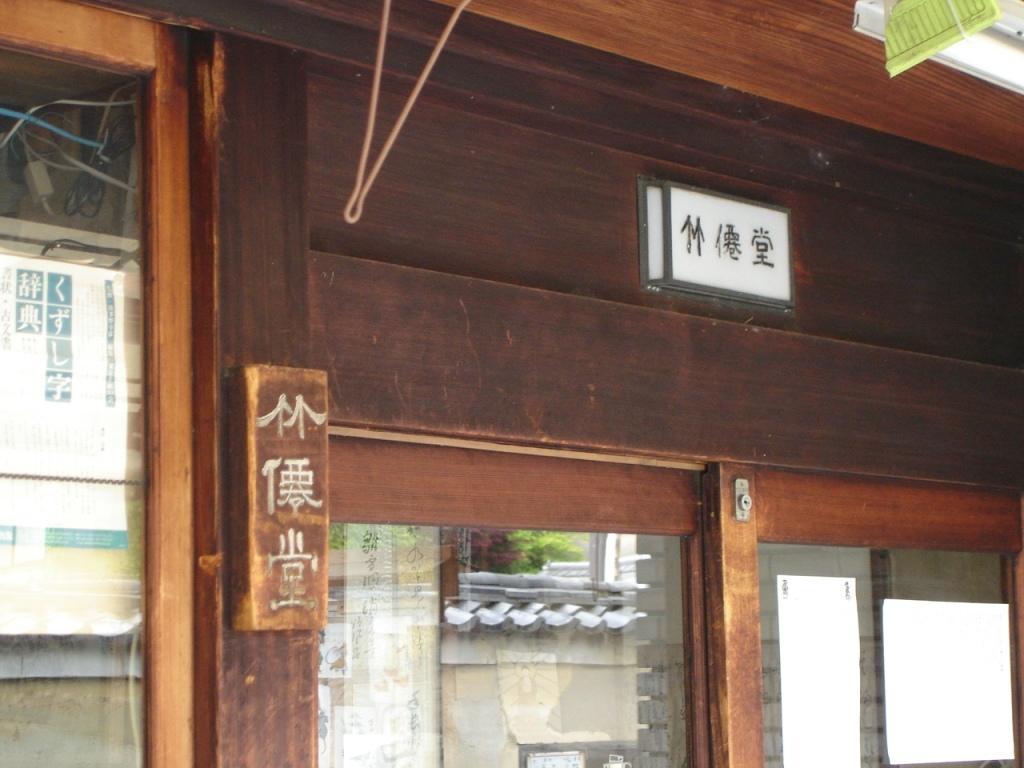Could you give a brief overview of what you see in this image? It is the picture of a door and the door is made up of wood and on the left side there is a window. 